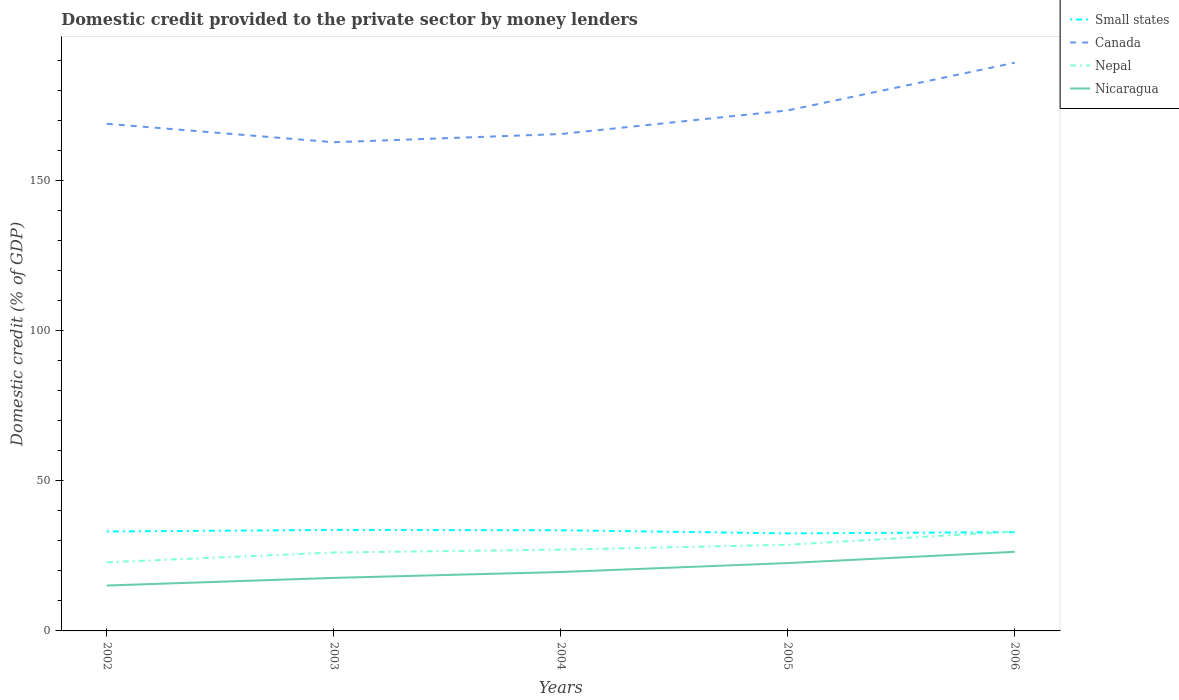How many different coloured lines are there?
Keep it short and to the point. 4. Is the number of lines equal to the number of legend labels?
Your answer should be very brief. Yes. Across all years, what is the maximum domestic credit provided to the private sector by money lenders in Nicaragua?
Ensure brevity in your answer.  15.13. What is the total domestic credit provided to the private sector by money lenders in Canada in the graph?
Ensure brevity in your answer.  3.41. What is the difference between the highest and the second highest domestic credit provided to the private sector by money lenders in Small states?
Offer a terse response. 1.15. Is the domestic credit provided to the private sector by money lenders in Canada strictly greater than the domestic credit provided to the private sector by money lenders in Small states over the years?
Offer a terse response. No. Does the graph contain any zero values?
Provide a short and direct response. No. Does the graph contain grids?
Your answer should be compact. No. How many legend labels are there?
Your answer should be very brief. 4. What is the title of the graph?
Provide a succinct answer. Domestic credit provided to the private sector by money lenders. Does "Uganda" appear as one of the legend labels in the graph?
Your response must be concise. No. What is the label or title of the X-axis?
Give a very brief answer. Years. What is the label or title of the Y-axis?
Ensure brevity in your answer.  Domestic credit (% of GDP). What is the Domestic credit (% of GDP) in Small states in 2002?
Provide a succinct answer. 33.15. What is the Domestic credit (% of GDP) in Canada in 2002?
Ensure brevity in your answer.  169.06. What is the Domestic credit (% of GDP) in Nepal in 2002?
Provide a succinct answer. 22.87. What is the Domestic credit (% of GDP) of Nicaragua in 2002?
Provide a short and direct response. 15.13. What is the Domestic credit (% of GDP) in Small states in 2003?
Your response must be concise. 33.67. What is the Domestic credit (% of GDP) of Canada in 2003?
Your response must be concise. 162.91. What is the Domestic credit (% of GDP) of Nepal in 2003?
Offer a terse response. 26.14. What is the Domestic credit (% of GDP) of Nicaragua in 2003?
Offer a terse response. 17.68. What is the Domestic credit (% of GDP) in Small states in 2004?
Provide a short and direct response. 33.56. What is the Domestic credit (% of GDP) of Canada in 2004?
Keep it short and to the point. 165.65. What is the Domestic credit (% of GDP) of Nepal in 2004?
Offer a very short reply. 27.1. What is the Domestic credit (% of GDP) of Nicaragua in 2004?
Make the answer very short. 19.64. What is the Domestic credit (% of GDP) of Small states in 2005?
Provide a succinct answer. 32.52. What is the Domestic credit (% of GDP) of Canada in 2005?
Offer a terse response. 173.52. What is the Domestic credit (% of GDP) of Nepal in 2005?
Keep it short and to the point. 28.73. What is the Domestic credit (% of GDP) in Nicaragua in 2005?
Make the answer very short. 22.62. What is the Domestic credit (% of GDP) of Small states in 2006?
Give a very brief answer. 32.92. What is the Domestic credit (% of GDP) of Canada in 2006?
Your answer should be compact. 189.43. What is the Domestic credit (% of GDP) in Nepal in 2006?
Keep it short and to the point. 33.15. What is the Domestic credit (% of GDP) in Nicaragua in 2006?
Provide a succinct answer. 26.37. Across all years, what is the maximum Domestic credit (% of GDP) in Small states?
Provide a succinct answer. 33.67. Across all years, what is the maximum Domestic credit (% of GDP) of Canada?
Offer a very short reply. 189.43. Across all years, what is the maximum Domestic credit (% of GDP) of Nepal?
Keep it short and to the point. 33.15. Across all years, what is the maximum Domestic credit (% of GDP) in Nicaragua?
Provide a short and direct response. 26.37. Across all years, what is the minimum Domestic credit (% of GDP) in Small states?
Keep it short and to the point. 32.52. Across all years, what is the minimum Domestic credit (% of GDP) in Canada?
Ensure brevity in your answer.  162.91. Across all years, what is the minimum Domestic credit (% of GDP) of Nepal?
Your answer should be very brief. 22.87. Across all years, what is the minimum Domestic credit (% of GDP) in Nicaragua?
Make the answer very short. 15.13. What is the total Domestic credit (% of GDP) of Small states in the graph?
Your response must be concise. 165.81. What is the total Domestic credit (% of GDP) in Canada in the graph?
Your answer should be compact. 860.57. What is the total Domestic credit (% of GDP) in Nepal in the graph?
Give a very brief answer. 137.99. What is the total Domestic credit (% of GDP) in Nicaragua in the graph?
Ensure brevity in your answer.  101.44. What is the difference between the Domestic credit (% of GDP) of Small states in 2002 and that in 2003?
Keep it short and to the point. -0.53. What is the difference between the Domestic credit (% of GDP) of Canada in 2002 and that in 2003?
Your answer should be very brief. 6.15. What is the difference between the Domestic credit (% of GDP) of Nepal in 2002 and that in 2003?
Ensure brevity in your answer.  -3.27. What is the difference between the Domestic credit (% of GDP) of Nicaragua in 2002 and that in 2003?
Give a very brief answer. -2.55. What is the difference between the Domestic credit (% of GDP) in Small states in 2002 and that in 2004?
Make the answer very short. -0.41. What is the difference between the Domestic credit (% of GDP) in Canada in 2002 and that in 2004?
Keep it short and to the point. 3.41. What is the difference between the Domestic credit (% of GDP) in Nepal in 2002 and that in 2004?
Provide a short and direct response. -4.23. What is the difference between the Domestic credit (% of GDP) of Nicaragua in 2002 and that in 2004?
Make the answer very short. -4.51. What is the difference between the Domestic credit (% of GDP) in Small states in 2002 and that in 2005?
Ensure brevity in your answer.  0.63. What is the difference between the Domestic credit (% of GDP) in Canada in 2002 and that in 2005?
Your answer should be compact. -4.45. What is the difference between the Domestic credit (% of GDP) in Nepal in 2002 and that in 2005?
Your answer should be compact. -5.86. What is the difference between the Domestic credit (% of GDP) of Nicaragua in 2002 and that in 2005?
Provide a short and direct response. -7.49. What is the difference between the Domestic credit (% of GDP) in Small states in 2002 and that in 2006?
Your answer should be very brief. 0.23. What is the difference between the Domestic credit (% of GDP) in Canada in 2002 and that in 2006?
Ensure brevity in your answer.  -20.36. What is the difference between the Domestic credit (% of GDP) of Nepal in 2002 and that in 2006?
Provide a short and direct response. -10.28. What is the difference between the Domestic credit (% of GDP) of Nicaragua in 2002 and that in 2006?
Your response must be concise. -11.24. What is the difference between the Domestic credit (% of GDP) in Small states in 2003 and that in 2004?
Give a very brief answer. 0.12. What is the difference between the Domestic credit (% of GDP) in Canada in 2003 and that in 2004?
Give a very brief answer. -2.74. What is the difference between the Domestic credit (% of GDP) of Nepal in 2003 and that in 2004?
Ensure brevity in your answer.  -0.95. What is the difference between the Domestic credit (% of GDP) in Nicaragua in 2003 and that in 2004?
Provide a succinct answer. -1.96. What is the difference between the Domestic credit (% of GDP) in Small states in 2003 and that in 2005?
Make the answer very short. 1.15. What is the difference between the Domestic credit (% of GDP) of Canada in 2003 and that in 2005?
Your answer should be compact. -10.6. What is the difference between the Domestic credit (% of GDP) of Nepal in 2003 and that in 2005?
Your response must be concise. -2.58. What is the difference between the Domestic credit (% of GDP) in Nicaragua in 2003 and that in 2005?
Give a very brief answer. -4.94. What is the difference between the Domestic credit (% of GDP) in Small states in 2003 and that in 2006?
Offer a very short reply. 0.76. What is the difference between the Domestic credit (% of GDP) of Canada in 2003 and that in 2006?
Make the answer very short. -26.51. What is the difference between the Domestic credit (% of GDP) in Nepal in 2003 and that in 2006?
Your answer should be very brief. -7.01. What is the difference between the Domestic credit (% of GDP) of Nicaragua in 2003 and that in 2006?
Your answer should be compact. -8.69. What is the difference between the Domestic credit (% of GDP) of Small states in 2004 and that in 2005?
Provide a succinct answer. 1.04. What is the difference between the Domestic credit (% of GDP) of Canada in 2004 and that in 2005?
Offer a very short reply. -7.87. What is the difference between the Domestic credit (% of GDP) of Nepal in 2004 and that in 2005?
Ensure brevity in your answer.  -1.63. What is the difference between the Domestic credit (% of GDP) of Nicaragua in 2004 and that in 2005?
Offer a terse response. -2.98. What is the difference between the Domestic credit (% of GDP) of Small states in 2004 and that in 2006?
Offer a terse response. 0.64. What is the difference between the Domestic credit (% of GDP) of Canada in 2004 and that in 2006?
Your response must be concise. -23.77. What is the difference between the Domestic credit (% of GDP) of Nepal in 2004 and that in 2006?
Your response must be concise. -6.05. What is the difference between the Domestic credit (% of GDP) of Nicaragua in 2004 and that in 2006?
Your response must be concise. -6.73. What is the difference between the Domestic credit (% of GDP) of Small states in 2005 and that in 2006?
Offer a terse response. -0.4. What is the difference between the Domestic credit (% of GDP) of Canada in 2005 and that in 2006?
Give a very brief answer. -15.91. What is the difference between the Domestic credit (% of GDP) of Nepal in 2005 and that in 2006?
Make the answer very short. -4.43. What is the difference between the Domestic credit (% of GDP) in Nicaragua in 2005 and that in 2006?
Provide a short and direct response. -3.75. What is the difference between the Domestic credit (% of GDP) of Small states in 2002 and the Domestic credit (% of GDP) of Canada in 2003?
Your response must be concise. -129.77. What is the difference between the Domestic credit (% of GDP) of Small states in 2002 and the Domestic credit (% of GDP) of Nepal in 2003?
Keep it short and to the point. 7. What is the difference between the Domestic credit (% of GDP) of Small states in 2002 and the Domestic credit (% of GDP) of Nicaragua in 2003?
Offer a terse response. 15.47. What is the difference between the Domestic credit (% of GDP) in Canada in 2002 and the Domestic credit (% of GDP) in Nepal in 2003?
Provide a succinct answer. 142.92. What is the difference between the Domestic credit (% of GDP) in Canada in 2002 and the Domestic credit (% of GDP) in Nicaragua in 2003?
Your answer should be compact. 151.38. What is the difference between the Domestic credit (% of GDP) in Nepal in 2002 and the Domestic credit (% of GDP) in Nicaragua in 2003?
Your answer should be compact. 5.19. What is the difference between the Domestic credit (% of GDP) of Small states in 2002 and the Domestic credit (% of GDP) of Canada in 2004?
Ensure brevity in your answer.  -132.5. What is the difference between the Domestic credit (% of GDP) in Small states in 2002 and the Domestic credit (% of GDP) in Nepal in 2004?
Provide a succinct answer. 6.05. What is the difference between the Domestic credit (% of GDP) in Small states in 2002 and the Domestic credit (% of GDP) in Nicaragua in 2004?
Offer a terse response. 13.51. What is the difference between the Domestic credit (% of GDP) in Canada in 2002 and the Domestic credit (% of GDP) in Nepal in 2004?
Offer a terse response. 141.97. What is the difference between the Domestic credit (% of GDP) in Canada in 2002 and the Domestic credit (% of GDP) in Nicaragua in 2004?
Offer a very short reply. 149.43. What is the difference between the Domestic credit (% of GDP) of Nepal in 2002 and the Domestic credit (% of GDP) of Nicaragua in 2004?
Ensure brevity in your answer.  3.23. What is the difference between the Domestic credit (% of GDP) of Small states in 2002 and the Domestic credit (% of GDP) of Canada in 2005?
Offer a very short reply. -140.37. What is the difference between the Domestic credit (% of GDP) in Small states in 2002 and the Domestic credit (% of GDP) in Nepal in 2005?
Your response must be concise. 4.42. What is the difference between the Domestic credit (% of GDP) of Small states in 2002 and the Domestic credit (% of GDP) of Nicaragua in 2005?
Provide a short and direct response. 10.53. What is the difference between the Domestic credit (% of GDP) in Canada in 2002 and the Domestic credit (% of GDP) in Nepal in 2005?
Your response must be concise. 140.34. What is the difference between the Domestic credit (% of GDP) in Canada in 2002 and the Domestic credit (% of GDP) in Nicaragua in 2005?
Your response must be concise. 146.45. What is the difference between the Domestic credit (% of GDP) in Nepal in 2002 and the Domestic credit (% of GDP) in Nicaragua in 2005?
Provide a succinct answer. 0.25. What is the difference between the Domestic credit (% of GDP) in Small states in 2002 and the Domestic credit (% of GDP) in Canada in 2006?
Make the answer very short. -156.28. What is the difference between the Domestic credit (% of GDP) of Small states in 2002 and the Domestic credit (% of GDP) of Nepal in 2006?
Offer a terse response. -0.01. What is the difference between the Domestic credit (% of GDP) of Small states in 2002 and the Domestic credit (% of GDP) of Nicaragua in 2006?
Provide a short and direct response. 6.77. What is the difference between the Domestic credit (% of GDP) in Canada in 2002 and the Domestic credit (% of GDP) in Nepal in 2006?
Offer a very short reply. 135.91. What is the difference between the Domestic credit (% of GDP) of Canada in 2002 and the Domestic credit (% of GDP) of Nicaragua in 2006?
Give a very brief answer. 142.69. What is the difference between the Domestic credit (% of GDP) in Nepal in 2002 and the Domestic credit (% of GDP) in Nicaragua in 2006?
Offer a very short reply. -3.5. What is the difference between the Domestic credit (% of GDP) in Small states in 2003 and the Domestic credit (% of GDP) in Canada in 2004?
Your answer should be very brief. -131.98. What is the difference between the Domestic credit (% of GDP) of Small states in 2003 and the Domestic credit (% of GDP) of Nepal in 2004?
Keep it short and to the point. 6.58. What is the difference between the Domestic credit (% of GDP) of Small states in 2003 and the Domestic credit (% of GDP) of Nicaragua in 2004?
Your answer should be very brief. 14.03. What is the difference between the Domestic credit (% of GDP) of Canada in 2003 and the Domestic credit (% of GDP) of Nepal in 2004?
Your answer should be very brief. 135.82. What is the difference between the Domestic credit (% of GDP) in Canada in 2003 and the Domestic credit (% of GDP) in Nicaragua in 2004?
Offer a very short reply. 143.28. What is the difference between the Domestic credit (% of GDP) of Nepal in 2003 and the Domestic credit (% of GDP) of Nicaragua in 2004?
Your answer should be compact. 6.5. What is the difference between the Domestic credit (% of GDP) of Small states in 2003 and the Domestic credit (% of GDP) of Canada in 2005?
Give a very brief answer. -139.85. What is the difference between the Domestic credit (% of GDP) in Small states in 2003 and the Domestic credit (% of GDP) in Nepal in 2005?
Provide a succinct answer. 4.95. What is the difference between the Domestic credit (% of GDP) of Small states in 2003 and the Domestic credit (% of GDP) of Nicaragua in 2005?
Ensure brevity in your answer.  11.05. What is the difference between the Domestic credit (% of GDP) in Canada in 2003 and the Domestic credit (% of GDP) in Nepal in 2005?
Provide a short and direct response. 134.19. What is the difference between the Domestic credit (% of GDP) in Canada in 2003 and the Domestic credit (% of GDP) in Nicaragua in 2005?
Your answer should be very brief. 140.3. What is the difference between the Domestic credit (% of GDP) of Nepal in 2003 and the Domestic credit (% of GDP) of Nicaragua in 2005?
Provide a short and direct response. 3.52. What is the difference between the Domestic credit (% of GDP) in Small states in 2003 and the Domestic credit (% of GDP) in Canada in 2006?
Your answer should be compact. -155.75. What is the difference between the Domestic credit (% of GDP) in Small states in 2003 and the Domestic credit (% of GDP) in Nepal in 2006?
Provide a short and direct response. 0.52. What is the difference between the Domestic credit (% of GDP) of Small states in 2003 and the Domestic credit (% of GDP) of Nicaragua in 2006?
Your response must be concise. 7.3. What is the difference between the Domestic credit (% of GDP) in Canada in 2003 and the Domestic credit (% of GDP) in Nepal in 2006?
Offer a terse response. 129.76. What is the difference between the Domestic credit (% of GDP) of Canada in 2003 and the Domestic credit (% of GDP) of Nicaragua in 2006?
Provide a short and direct response. 136.54. What is the difference between the Domestic credit (% of GDP) in Nepal in 2003 and the Domestic credit (% of GDP) in Nicaragua in 2006?
Your answer should be compact. -0.23. What is the difference between the Domestic credit (% of GDP) in Small states in 2004 and the Domestic credit (% of GDP) in Canada in 2005?
Ensure brevity in your answer.  -139.96. What is the difference between the Domestic credit (% of GDP) in Small states in 2004 and the Domestic credit (% of GDP) in Nepal in 2005?
Your answer should be compact. 4.83. What is the difference between the Domestic credit (% of GDP) of Small states in 2004 and the Domestic credit (% of GDP) of Nicaragua in 2005?
Your answer should be very brief. 10.94. What is the difference between the Domestic credit (% of GDP) of Canada in 2004 and the Domestic credit (% of GDP) of Nepal in 2005?
Your answer should be compact. 136.92. What is the difference between the Domestic credit (% of GDP) in Canada in 2004 and the Domestic credit (% of GDP) in Nicaragua in 2005?
Provide a short and direct response. 143.03. What is the difference between the Domestic credit (% of GDP) in Nepal in 2004 and the Domestic credit (% of GDP) in Nicaragua in 2005?
Provide a succinct answer. 4.48. What is the difference between the Domestic credit (% of GDP) of Small states in 2004 and the Domestic credit (% of GDP) of Canada in 2006?
Your answer should be compact. -155.87. What is the difference between the Domestic credit (% of GDP) in Small states in 2004 and the Domestic credit (% of GDP) in Nepal in 2006?
Provide a succinct answer. 0.41. What is the difference between the Domestic credit (% of GDP) in Small states in 2004 and the Domestic credit (% of GDP) in Nicaragua in 2006?
Offer a very short reply. 7.18. What is the difference between the Domestic credit (% of GDP) in Canada in 2004 and the Domestic credit (% of GDP) in Nepal in 2006?
Your response must be concise. 132.5. What is the difference between the Domestic credit (% of GDP) of Canada in 2004 and the Domestic credit (% of GDP) of Nicaragua in 2006?
Offer a terse response. 139.28. What is the difference between the Domestic credit (% of GDP) of Nepal in 2004 and the Domestic credit (% of GDP) of Nicaragua in 2006?
Your response must be concise. 0.72. What is the difference between the Domestic credit (% of GDP) of Small states in 2005 and the Domestic credit (% of GDP) of Canada in 2006?
Give a very brief answer. -156.91. What is the difference between the Domestic credit (% of GDP) in Small states in 2005 and the Domestic credit (% of GDP) in Nepal in 2006?
Your answer should be very brief. -0.63. What is the difference between the Domestic credit (% of GDP) in Small states in 2005 and the Domestic credit (% of GDP) in Nicaragua in 2006?
Your response must be concise. 6.15. What is the difference between the Domestic credit (% of GDP) in Canada in 2005 and the Domestic credit (% of GDP) in Nepal in 2006?
Give a very brief answer. 140.37. What is the difference between the Domestic credit (% of GDP) of Canada in 2005 and the Domestic credit (% of GDP) of Nicaragua in 2006?
Offer a very short reply. 147.15. What is the difference between the Domestic credit (% of GDP) in Nepal in 2005 and the Domestic credit (% of GDP) in Nicaragua in 2006?
Ensure brevity in your answer.  2.35. What is the average Domestic credit (% of GDP) in Small states per year?
Offer a terse response. 33.16. What is the average Domestic credit (% of GDP) in Canada per year?
Offer a very short reply. 172.11. What is the average Domestic credit (% of GDP) of Nepal per year?
Your answer should be very brief. 27.6. What is the average Domestic credit (% of GDP) of Nicaragua per year?
Your answer should be compact. 20.29. In the year 2002, what is the difference between the Domestic credit (% of GDP) of Small states and Domestic credit (% of GDP) of Canada?
Offer a terse response. -135.92. In the year 2002, what is the difference between the Domestic credit (% of GDP) of Small states and Domestic credit (% of GDP) of Nepal?
Your answer should be compact. 10.28. In the year 2002, what is the difference between the Domestic credit (% of GDP) of Small states and Domestic credit (% of GDP) of Nicaragua?
Provide a short and direct response. 18.02. In the year 2002, what is the difference between the Domestic credit (% of GDP) in Canada and Domestic credit (% of GDP) in Nepal?
Make the answer very short. 146.2. In the year 2002, what is the difference between the Domestic credit (% of GDP) of Canada and Domestic credit (% of GDP) of Nicaragua?
Provide a short and direct response. 153.93. In the year 2002, what is the difference between the Domestic credit (% of GDP) in Nepal and Domestic credit (% of GDP) in Nicaragua?
Provide a short and direct response. 7.74. In the year 2003, what is the difference between the Domestic credit (% of GDP) of Small states and Domestic credit (% of GDP) of Canada?
Give a very brief answer. -129.24. In the year 2003, what is the difference between the Domestic credit (% of GDP) of Small states and Domestic credit (% of GDP) of Nepal?
Provide a short and direct response. 7.53. In the year 2003, what is the difference between the Domestic credit (% of GDP) in Small states and Domestic credit (% of GDP) in Nicaragua?
Your answer should be compact. 15.99. In the year 2003, what is the difference between the Domestic credit (% of GDP) in Canada and Domestic credit (% of GDP) in Nepal?
Keep it short and to the point. 136.77. In the year 2003, what is the difference between the Domestic credit (% of GDP) in Canada and Domestic credit (% of GDP) in Nicaragua?
Offer a very short reply. 145.23. In the year 2003, what is the difference between the Domestic credit (% of GDP) in Nepal and Domestic credit (% of GDP) in Nicaragua?
Offer a very short reply. 8.46. In the year 2004, what is the difference between the Domestic credit (% of GDP) of Small states and Domestic credit (% of GDP) of Canada?
Keep it short and to the point. -132.09. In the year 2004, what is the difference between the Domestic credit (% of GDP) of Small states and Domestic credit (% of GDP) of Nepal?
Provide a succinct answer. 6.46. In the year 2004, what is the difference between the Domestic credit (% of GDP) of Small states and Domestic credit (% of GDP) of Nicaragua?
Provide a succinct answer. 13.92. In the year 2004, what is the difference between the Domestic credit (% of GDP) of Canada and Domestic credit (% of GDP) of Nepal?
Provide a short and direct response. 138.55. In the year 2004, what is the difference between the Domestic credit (% of GDP) in Canada and Domestic credit (% of GDP) in Nicaragua?
Your answer should be compact. 146.01. In the year 2004, what is the difference between the Domestic credit (% of GDP) of Nepal and Domestic credit (% of GDP) of Nicaragua?
Offer a terse response. 7.46. In the year 2005, what is the difference between the Domestic credit (% of GDP) of Small states and Domestic credit (% of GDP) of Canada?
Keep it short and to the point. -141. In the year 2005, what is the difference between the Domestic credit (% of GDP) of Small states and Domestic credit (% of GDP) of Nepal?
Your answer should be compact. 3.79. In the year 2005, what is the difference between the Domestic credit (% of GDP) in Small states and Domestic credit (% of GDP) in Nicaragua?
Your answer should be compact. 9.9. In the year 2005, what is the difference between the Domestic credit (% of GDP) in Canada and Domestic credit (% of GDP) in Nepal?
Provide a short and direct response. 144.79. In the year 2005, what is the difference between the Domestic credit (% of GDP) of Canada and Domestic credit (% of GDP) of Nicaragua?
Offer a very short reply. 150.9. In the year 2005, what is the difference between the Domestic credit (% of GDP) of Nepal and Domestic credit (% of GDP) of Nicaragua?
Your answer should be very brief. 6.11. In the year 2006, what is the difference between the Domestic credit (% of GDP) of Small states and Domestic credit (% of GDP) of Canada?
Provide a short and direct response. -156.51. In the year 2006, what is the difference between the Domestic credit (% of GDP) of Small states and Domestic credit (% of GDP) of Nepal?
Provide a succinct answer. -0.23. In the year 2006, what is the difference between the Domestic credit (% of GDP) of Small states and Domestic credit (% of GDP) of Nicaragua?
Your answer should be compact. 6.54. In the year 2006, what is the difference between the Domestic credit (% of GDP) of Canada and Domestic credit (% of GDP) of Nepal?
Provide a short and direct response. 156.27. In the year 2006, what is the difference between the Domestic credit (% of GDP) of Canada and Domestic credit (% of GDP) of Nicaragua?
Offer a very short reply. 163.05. In the year 2006, what is the difference between the Domestic credit (% of GDP) in Nepal and Domestic credit (% of GDP) in Nicaragua?
Provide a short and direct response. 6.78. What is the ratio of the Domestic credit (% of GDP) of Small states in 2002 to that in 2003?
Give a very brief answer. 0.98. What is the ratio of the Domestic credit (% of GDP) of Canada in 2002 to that in 2003?
Offer a very short reply. 1.04. What is the ratio of the Domestic credit (% of GDP) in Nepal in 2002 to that in 2003?
Offer a terse response. 0.87. What is the ratio of the Domestic credit (% of GDP) of Nicaragua in 2002 to that in 2003?
Give a very brief answer. 0.86. What is the ratio of the Domestic credit (% of GDP) in Small states in 2002 to that in 2004?
Give a very brief answer. 0.99. What is the ratio of the Domestic credit (% of GDP) in Canada in 2002 to that in 2004?
Your response must be concise. 1.02. What is the ratio of the Domestic credit (% of GDP) in Nepal in 2002 to that in 2004?
Keep it short and to the point. 0.84. What is the ratio of the Domestic credit (% of GDP) in Nicaragua in 2002 to that in 2004?
Keep it short and to the point. 0.77. What is the ratio of the Domestic credit (% of GDP) of Small states in 2002 to that in 2005?
Make the answer very short. 1.02. What is the ratio of the Domestic credit (% of GDP) of Canada in 2002 to that in 2005?
Offer a terse response. 0.97. What is the ratio of the Domestic credit (% of GDP) of Nepal in 2002 to that in 2005?
Provide a succinct answer. 0.8. What is the ratio of the Domestic credit (% of GDP) in Nicaragua in 2002 to that in 2005?
Make the answer very short. 0.67. What is the ratio of the Domestic credit (% of GDP) in Small states in 2002 to that in 2006?
Make the answer very short. 1.01. What is the ratio of the Domestic credit (% of GDP) of Canada in 2002 to that in 2006?
Provide a short and direct response. 0.89. What is the ratio of the Domestic credit (% of GDP) of Nepal in 2002 to that in 2006?
Provide a succinct answer. 0.69. What is the ratio of the Domestic credit (% of GDP) of Nicaragua in 2002 to that in 2006?
Offer a terse response. 0.57. What is the ratio of the Domestic credit (% of GDP) of Small states in 2003 to that in 2004?
Your response must be concise. 1. What is the ratio of the Domestic credit (% of GDP) in Canada in 2003 to that in 2004?
Offer a very short reply. 0.98. What is the ratio of the Domestic credit (% of GDP) of Nepal in 2003 to that in 2004?
Provide a short and direct response. 0.96. What is the ratio of the Domestic credit (% of GDP) in Nicaragua in 2003 to that in 2004?
Give a very brief answer. 0.9. What is the ratio of the Domestic credit (% of GDP) in Small states in 2003 to that in 2005?
Offer a very short reply. 1.04. What is the ratio of the Domestic credit (% of GDP) of Canada in 2003 to that in 2005?
Your answer should be very brief. 0.94. What is the ratio of the Domestic credit (% of GDP) of Nepal in 2003 to that in 2005?
Ensure brevity in your answer.  0.91. What is the ratio of the Domestic credit (% of GDP) of Nicaragua in 2003 to that in 2005?
Provide a succinct answer. 0.78. What is the ratio of the Domestic credit (% of GDP) of Canada in 2003 to that in 2006?
Give a very brief answer. 0.86. What is the ratio of the Domestic credit (% of GDP) of Nepal in 2003 to that in 2006?
Offer a very short reply. 0.79. What is the ratio of the Domestic credit (% of GDP) of Nicaragua in 2003 to that in 2006?
Provide a succinct answer. 0.67. What is the ratio of the Domestic credit (% of GDP) in Small states in 2004 to that in 2005?
Your response must be concise. 1.03. What is the ratio of the Domestic credit (% of GDP) in Canada in 2004 to that in 2005?
Your answer should be compact. 0.95. What is the ratio of the Domestic credit (% of GDP) in Nepal in 2004 to that in 2005?
Your response must be concise. 0.94. What is the ratio of the Domestic credit (% of GDP) in Nicaragua in 2004 to that in 2005?
Provide a succinct answer. 0.87. What is the ratio of the Domestic credit (% of GDP) of Small states in 2004 to that in 2006?
Offer a very short reply. 1.02. What is the ratio of the Domestic credit (% of GDP) of Canada in 2004 to that in 2006?
Keep it short and to the point. 0.87. What is the ratio of the Domestic credit (% of GDP) in Nepal in 2004 to that in 2006?
Provide a succinct answer. 0.82. What is the ratio of the Domestic credit (% of GDP) of Nicaragua in 2004 to that in 2006?
Your answer should be compact. 0.74. What is the ratio of the Domestic credit (% of GDP) in Small states in 2005 to that in 2006?
Ensure brevity in your answer.  0.99. What is the ratio of the Domestic credit (% of GDP) in Canada in 2005 to that in 2006?
Provide a short and direct response. 0.92. What is the ratio of the Domestic credit (% of GDP) of Nepal in 2005 to that in 2006?
Offer a terse response. 0.87. What is the ratio of the Domestic credit (% of GDP) of Nicaragua in 2005 to that in 2006?
Your answer should be very brief. 0.86. What is the difference between the highest and the second highest Domestic credit (% of GDP) of Small states?
Offer a terse response. 0.12. What is the difference between the highest and the second highest Domestic credit (% of GDP) in Canada?
Ensure brevity in your answer.  15.91. What is the difference between the highest and the second highest Domestic credit (% of GDP) of Nepal?
Ensure brevity in your answer.  4.43. What is the difference between the highest and the second highest Domestic credit (% of GDP) in Nicaragua?
Provide a succinct answer. 3.75. What is the difference between the highest and the lowest Domestic credit (% of GDP) in Small states?
Ensure brevity in your answer.  1.15. What is the difference between the highest and the lowest Domestic credit (% of GDP) in Canada?
Offer a very short reply. 26.51. What is the difference between the highest and the lowest Domestic credit (% of GDP) in Nepal?
Your answer should be compact. 10.28. What is the difference between the highest and the lowest Domestic credit (% of GDP) of Nicaragua?
Provide a short and direct response. 11.24. 